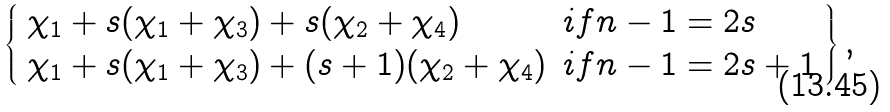<formula> <loc_0><loc_0><loc_500><loc_500>\left \{ \begin{array} { l l } \chi _ { 1 } + s ( \chi _ { 1 } + \chi _ { 3 } ) + s ( \chi _ { 2 } + \chi _ { 4 } ) & i f n - 1 = 2 s \\ \chi _ { 1 } + s ( \chi _ { 1 } + \chi _ { 3 } ) + ( s + 1 ) ( \chi _ { 2 } + \chi _ { 4 } ) & i f n - 1 = 2 s + 1 \end{array} \right \} ,</formula> 